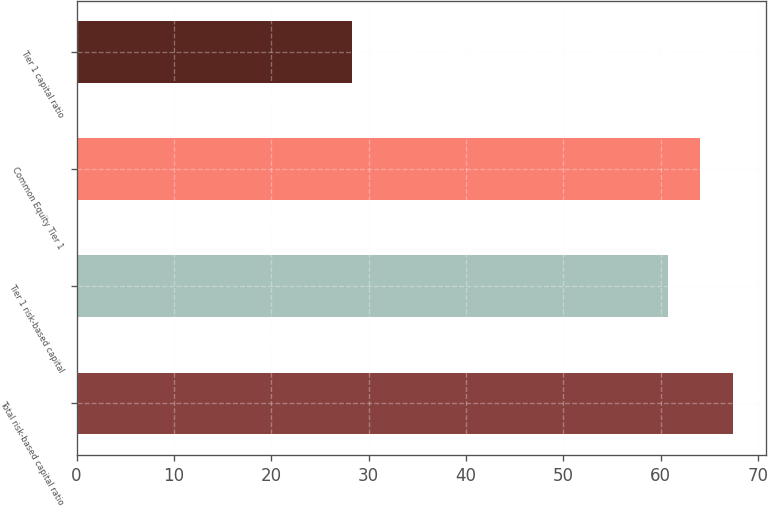Convert chart. <chart><loc_0><loc_0><loc_500><loc_500><bar_chart><fcel>Total risk-based capital ratio<fcel>Tier 1 risk-based capital<fcel>Common Equity Tier 1<fcel>Tier 1 capital ratio<nl><fcel>67.44<fcel>60.7<fcel>64.07<fcel>28.3<nl></chart> 